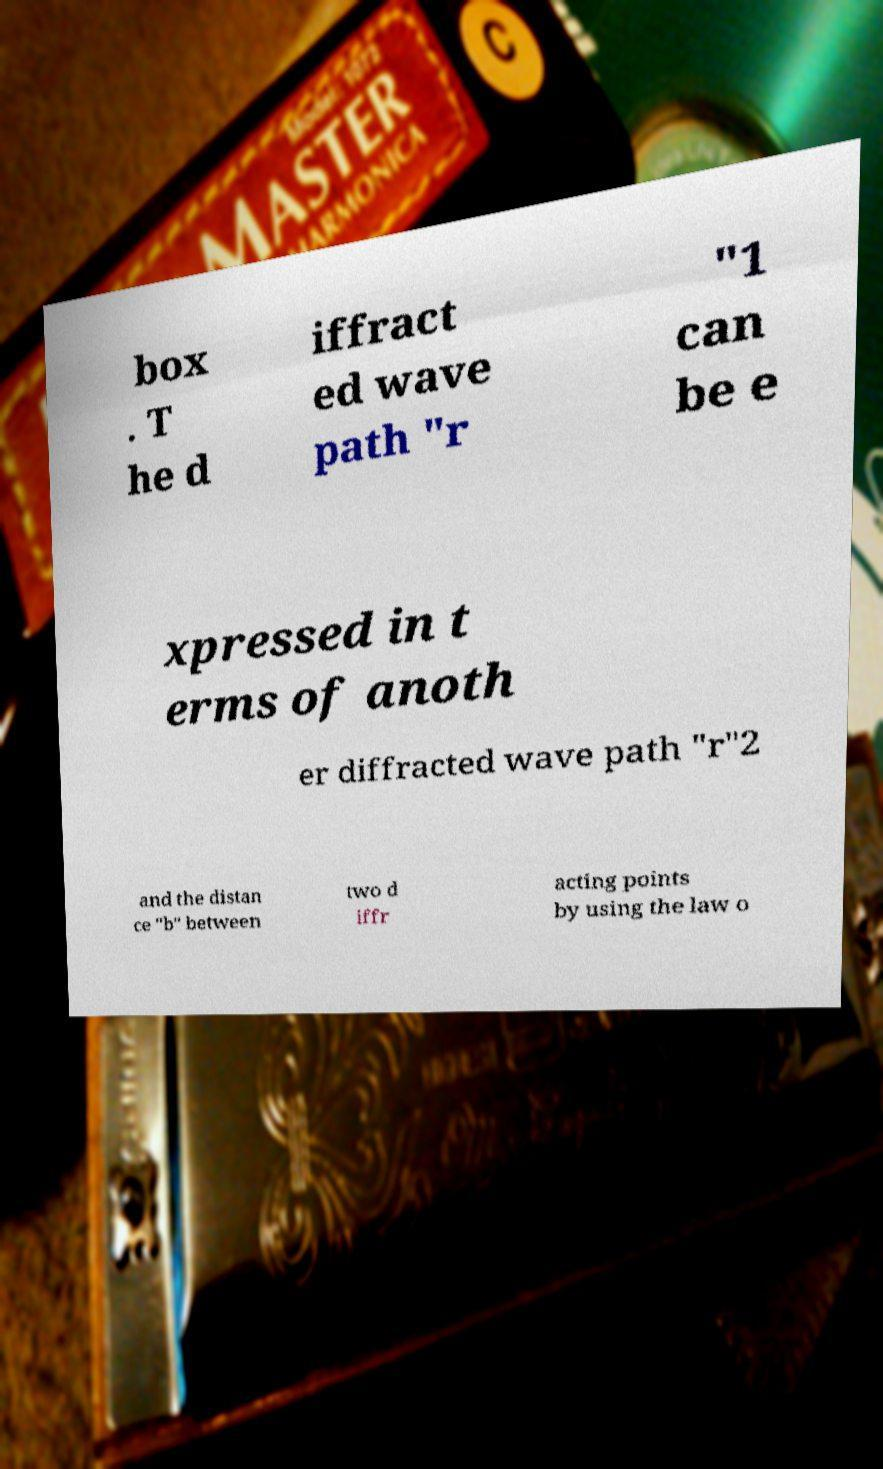Could you assist in decoding the text presented in this image and type it out clearly? box . T he d iffract ed wave path "r "1 can be e xpressed in t erms of anoth er diffracted wave path "r"2 and the distan ce "b" between two d iffr acting points by using the law o 